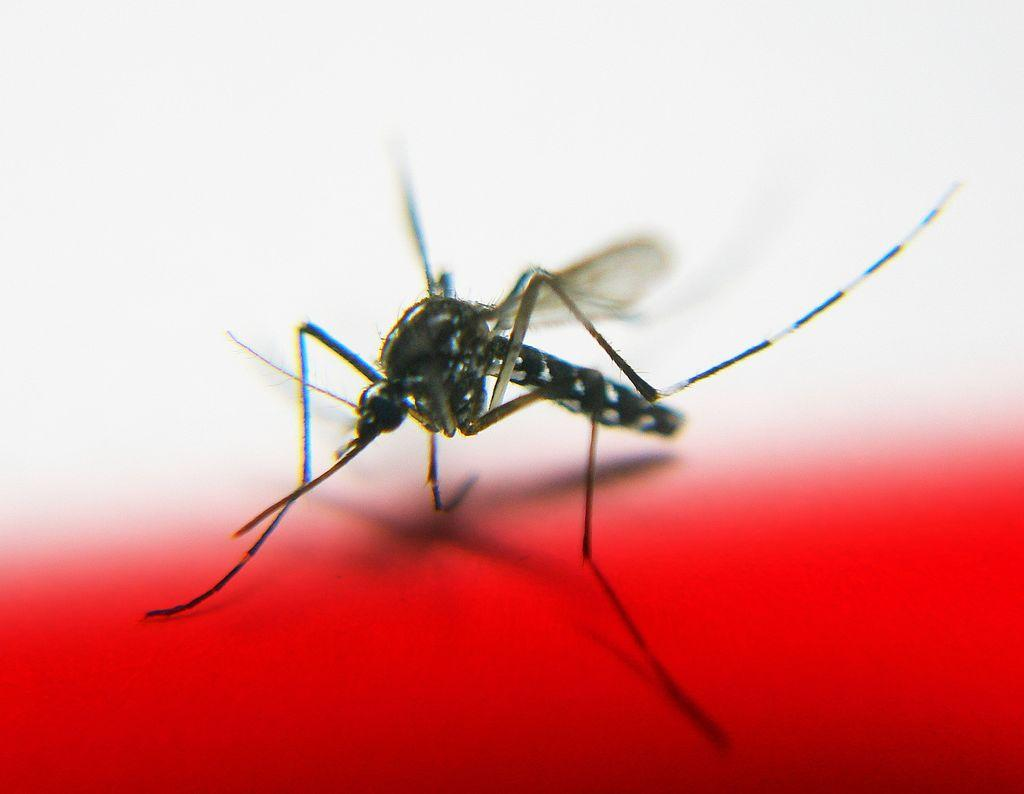What is the main subject of the image? There is a mosquito in the image. What color is the surface on which the mosquito is resting? The mosquito is on a red surface. What color is the background of the image? The background of the image is white. How many rings are being worn by the mosquito in the image? There are no rings visible on the mosquito in the image, as mosquitoes do not wear rings. 